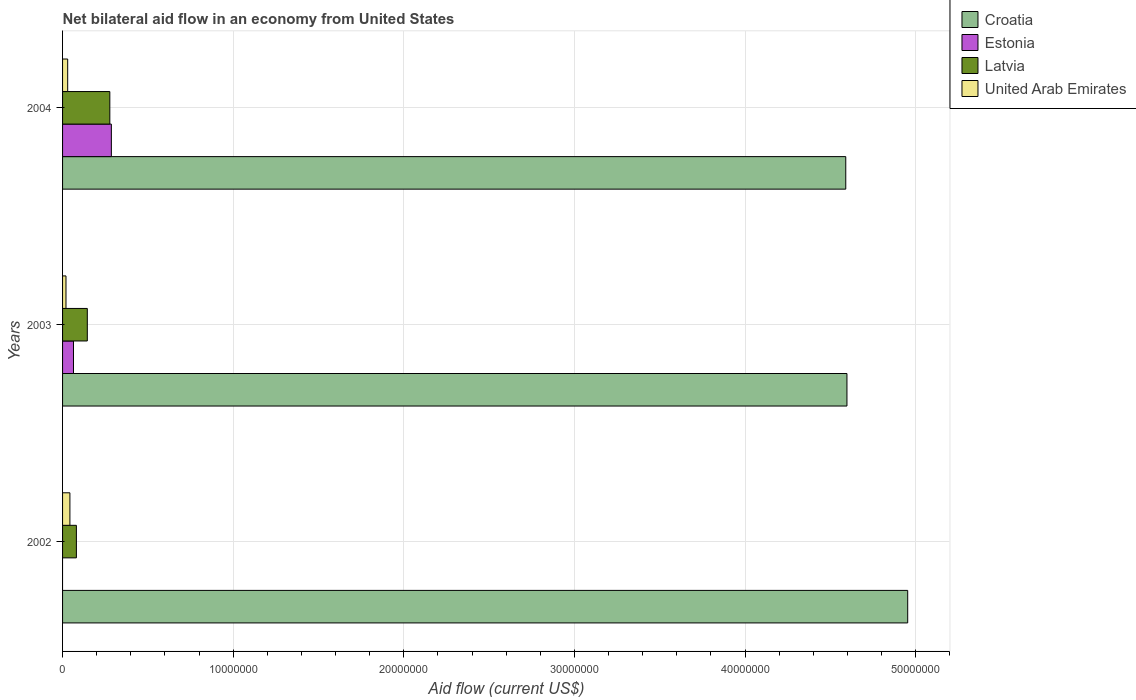Are the number of bars on each tick of the Y-axis equal?
Provide a short and direct response. No. How many bars are there on the 3rd tick from the top?
Offer a very short reply. 3. How many bars are there on the 1st tick from the bottom?
Make the answer very short. 3. What is the label of the 2nd group of bars from the top?
Provide a short and direct response. 2003. What is the net bilateral aid flow in Croatia in 2003?
Your answer should be very brief. 4.60e+07. Across all years, what is the maximum net bilateral aid flow in Estonia?
Your answer should be very brief. 2.86e+06. What is the total net bilateral aid flow in United Arab Emirates in the graph?
Your answer should be very brief. 9.30e+05. What is the difference between the net bilateral aid flow in Latvia in 2003 and that in 2004?
Your response must be concise. -1.32e+06. What is the difference between the net bilateral aid flow in Estonia in 2003 and the net bilateral aid flow in Latvia in 2002?
Make the answer very short. -1.70e+05. What is the average net bilateral aid flow in Estonia per year?
Provide a succinct answer. 1.17e+06. What is the ratio of the net bilateral aid flow in Estonia in 2003 to that in 2004?
Your answer should be very brief. 0.22. Is the net bilateral aid flow in United Arab Emirates in 2003 less than that in 2004?
Provide a short and direct response. Yes. Is the difference between the net bilateral aid flow in Latvia in 2003 and 2004 greater than the difference between the net bilateral aid flow in Estonia in 2003 and 2004?
Your response must be concise. Yes. What is the difference between the highest and the second highest net bilateral aid flow in Latvia?
Offer a terse response. 1.32e+06. What is the difference between the highest and the lowest net bilateral aid flow in Croatia?
Make the answer very short. 3.63e+06. In how many years, is the net bilateral aid flow in Latvia greater than the average net bilateral aid flow in Latvia taken over all years?
Provide a short and direct response. 1. Is it the case that in every year, the sum of the net bilateral aid flow in Latvia and net bilateral aid flow in Estonia is greater than the sum of net bilateral aid flow in Croatia and net bilateral aid flow in United Arab Emirates?
Provide a short and direct response. No. Are all the bars in the graph horizontal?
Keep it short and to the point. Yes. How many years are there in the graph?
Keep it short and to the point. 3. What is the difference between two consecutive major ticks on the X-axis?
Your answer should be very brief. 1.00e+07. Are the values on the major ticks of X-axis written in scientific E-notation?
Make the answer very short. No. Does the graph contain any zero values?
Offer a terse response. Yes. How are the legend labels stacked?
Offer a very short reply. Vertical. What is the title of the graph?
Your answer should be compact. Net bilateral aid flow in an economy from United States. Does "Kenya" appear as one of the legend labels in the graph?
Your answer should be compact. No. What is the label or title of the X-axis?
Your answer should be very brief. Aid flow (current US$). What is the Aid flow (current US$) of Croatia in 2002?
Your answer should be very brief. 4.95e+07. What is the Aid flow (current US$) in Latvia in 2002?
Offer a very short reply. 8.10e+05. What is the Aid flow (current US$) of United Arab Emirates in 2002?
Your answer should be very brief. 4.30e+05. What is the Aid flow (current US$) of Croatia in 2003?
Keep it short and to the point. 4.60e+07. What is the Aid flow (current US$) of Estonia in 2003?
Your answer should be very brief. 6.40e+05. What is the Aid flow (current US$) in Latvia in 2003?
Offer a very short reply. 1.45e+06. What is the Aid flow (current US$) of United Arab Emirates in 2003?
Provide a short and direct response. 2.00e+05. What is the Aid flow (current US$) in Croatia in 2004?
Offer a terse response. 4.59e+07. What is the Aid flow (current US$) of Estonia in 2004?
Offer a terse response. 2.86e+06. What is the Aid flow (current US$) in Latvia in 2004?
Provide a succinct answer. 2.77e+06. Across all years, what is the maximum Aid flow (current US$) in Croatia?
Make the answer very short. 4.95e+07. Across all years, what is the maximum Aid flow (current US$) in Estonia?
Your response must be concise. 2.86e+06. Across all years, what is the maximum Aid flow (current US$) of Latvia?
Provide a succinct answer. 2.77e+06. Across all years, what is the minimum Aid flow (current US$) in Croatia?
Your answer should be compact. 4.59e+07. Across all years, what is the minimum Aid flow (current US$) of Latvia?
Make the answer very short. 8.10e+05. Across all years, what is the minimum Aid flow (current US$) in United Arab Emirates?
Provide a succinct answer. 2.00e+05. What is the total Aid flow (current US$) in Croatia in the graph?
Give a very brief answer. 1.41e+08. What is the total Aid flow (current US$) of Estonia in the graph?
Your response must be concise. 3.50e+06. What is the total Aid flow (current US$) of Latvia in the graph?
Make the answer very short. 5.03e+06. What is the total Aid flow (current US$) in United Arab Emirates in the graph?
Offer a terse response. 9.30e+05. What is the difference between the Aid flow (current US$) in Croatia in 2002 and that in 2003?
Your answer should be very brief. 3.56e+06. What is the difference between the Aid flow (current US$) in Latvia in 2002 and that in 2003?
Keep it short and to the point. -6.40e+05. What is the difference between the Aid flow (current US$) of Croatia in 2002 and that in 2004?
Your response must be concise. 3.63e+06. What is the difference between the Aid flow (current US$) of Latvia in 2002 and that in 2004?
Provide a succinct answer. -1.96e+06. What is the difference between the Aid flow (current US$) of Estonia in 2003 and that in 2004?
Provide a short and direct response. -2.22e+06. What is the difference between the Aid flow (current US$) in Latvia in 2003 and that in 2004?
Give a very brief answer. -1.32e+06. What is the difference between the Aid flow (current US$) in United Arab Emirates in 2003 and that in 2004?
Provide a succinct answer. -1.00e+05. What is the difference between the Aid flow (current US$) of Croatia in 2002 and the Aid flow (current US$) of Estonia in 2003?
Offer a terse response. 4.89e+07. What is the difference between the Aid flow (current US$) in Croatia in 2002 and the Aid flow (current US$) in Latvia in 2003?
Make the answer very short. 4.81e+07. What is the difference between the Aid flow (current US$) of Croatia in 2002 and the Aid flow (current US$) of United Arab Emirates in 2003?
Keep it short and to the point. 4.93e+07. What is the difference between the Aid flow (current US$) in Croatia in 2002 and the Aid flow (current US$) in Estonia in 2004?
Keep it short and to the point. 4.67e+07. What is the difference between the Aid flow (current US$) of Croatia in 2002 and the Aid flow (current US$) of Latvia in 2004?
Make the answer very short. 4.68e+07. What is the difference between the Aid flow (current US$) of Croatia in 2002 and the Aid flow (current US$) of United Arab Emirates in 2004?
Provide a short and direct response. 4.92e+07. What is the difference between the Aid flow (current US$) of Latvia in 2002 and the Aid flow (current US$) of United Arab Emirates in 2004?
Give a very brief answer. 5.10e+05. What is the difference between the Aid flow (current US$) in Croatia in 2003 and the Aid flow (current US$) in Estonia in 2004?
Provide a succinct answer. 4.31e+07. What is the difference between the Aid flow (current US$) of Croatia in 2003 and the Aid flow (current US$) of Latvia in 2004?
Offer a terse response. 4.32e+07. What is the difference between the Aid flow (current US$) in Croatia in 2003 and the Aid flow (current US$) in United Arab Emirates in 2004?
Offer a very short reply. 4.57e+07. What is the difference between the Aid flow (current US$) in Estonia in 2003 and the Aid flow (current US$) in Latvia in 2004?
Keep it short and to the point. -2.13e+06. What is the difference between the Aid flow (current US$) of Estonia in 2003 and the Aid flow (current US$) of United Arab Emirates in 2004?
Give a very brief answer. 3.40e+05. What is the difference between the Aid flow (current US$) in Latvia in 2003 and the Aid flow (current US$) in United Arab Emirates in 2004?
Your response must be concise. 1.15e+06. What is the average Aid flow (current US$) in Croatia per year?
Your answer should be compact. 4.71e+07. What is the average Aid flow (current US$) in Estonia per year?
Offer a very short reply. 1.17e+06. What is the average Aid flow (current US$) of Latvia per year?
Keep it short and to the point. 1.68e+06. What is the average Aid flow (current US$) of United Arab Emirates per year?
Give a very brief answer. 3.10e+05. In the year 2002, what is the difference between the Aid flow (current US$) of Croatia and Aid flow (current US$) of Latvia?
Keep it short and to the point. 4.87e+07. In the year 2002, what is the difference between the Aid flow (current US$) of Croatia and Aid flow (current US$) of United Arab Emirates?
Keep it short and to the point. 4.91e+07. In the year 2002, what is the difference between the Aid flow (current US$) of Latvia and Aid flow (current US$) of United Arab Emirates?
Make the answer very short. 3.80e+05. In the year 2003, what is the difference between the Aid flow (current US$) in Croatia and Aid flow (current US$) in Estonia?
Your answer should be compact. 4.53e+07. In the year 2003, what is the difference between the Aid flow (current US$) of Croatia and Aid flow (current US$) of Latvia?
Make the answer very short. 4.45e+07. In the year 2003, what is the difference between the Aid flow (current US$) of Croatia and Aid flow (current US$) of United Arab Emirates?
Your answer should be very brief. 4.58e+07. In the year 2003, what is the difference between the Aid flow (current US$) in Estonia and Aid flow (current US$) in Latvia?
Your response must be concise. -8.10e+05. In the year 2003, what is the difference between the Aid flow (current US$) in Latvia and Aid flow (current US$) in United Arab Emirates?
Keep it short and to the point. 1.25e+06. In the year 2004, what is the difference between the Aid flow (current US$) in Croatia and Aid flow (current US$) in Estonia?
Give a very brief answer. 4.30e+07. In the year 2004, what is the difference between the Aid flow (current US$) of Croatia and Aid flow (current US$) of Latvia?
Offer a very short reply. 4.31e+07. In the year 2004, what is the difference between the Aid flow (current US$) in Croatia and Aid flow (current US$) in United Arab Emirates?
Your answer should be very brief. 4.56e+07. In the year 2004, what is the difference between the Aid flow (current US$) of Estonia and Aid flow (current US$) of United Arab Emirates?
Provide a succinct answer. 2.56e+06. In the year 2004, what is the difference between the Aid flow (current US$) of Latvia and Aid flow (current US$) of United Arab Emirates?
Offer a very short reply. 2.47e+06. What is the ratio of the Aid flow (current US$) of Croatia in 2002 to that in 2003?
Offer a terse response. 1.08. What is the ratio of the Aid flow (current US$) in Latvia in 2002 to that in 2003?
Offer a very short reply. 0.56. What is the ratio of the Aid flow (current US$) in United Arab Emirates in 2002 to that in 2003?
Keep it short and to the point. 2.15. What is the ratio of the Aid flow (current US$) in Croatia in 2002 to that in 2004?
Your answer should be very brief. 1.08. What is the ratio of the Aid flow (current US$) of Latvia in 2002 to that in 2004?
Offer a terse response. 0.29. What is the ratio of the Aid flow (current US$) in United Arab Emirates in 2002 to that in 2004?
Keep it short and to the point. 1.43. What is the ratio of the Aid flow (current US$) in Croatia in 2003 to that in 2004?
Your response must be concise. 1. What is the ratio of the Aid flow (current US$) of Estonia in 2003 to that in 2004?
Make the answer very short. 0.22. What is the ratio of the Aid flow (current US$) of Latvia in 2003 to that in 2004?
Provide a short and direct response. 0.52. What is the ratio of the Aid flow (current US$) in United Arab Emirates in 2003 to that in 2004?
Give a very brief answer. 0.67. What is the difference between the highest and the second highest Aid flow (current US$) of Croatia?
Provide a short and direct response. 3.56e+06. What is the difference between the highest and the second highest Aid flow (current US$) of Latvia?
Your response must be concise. 1.32e+06. What is the difference between the highest and the second highest Aid flow (current US$) in United Arab Emirates?
Provide a succinct answer. 1.30e+05. What is the difference between the highest and the lowest Aid flow (current US$) in Croatia?
Make the answer very short. 3.63e+06. What is the difference between the highest and the lowest Aid flow (current US$) in Estonia?
Your answer should be very brief. 2.86e+06. What is the difference between the highest and the lowest Aid flow (current US$) of Latvia?
Offer a terse response. 1.96e+06. 